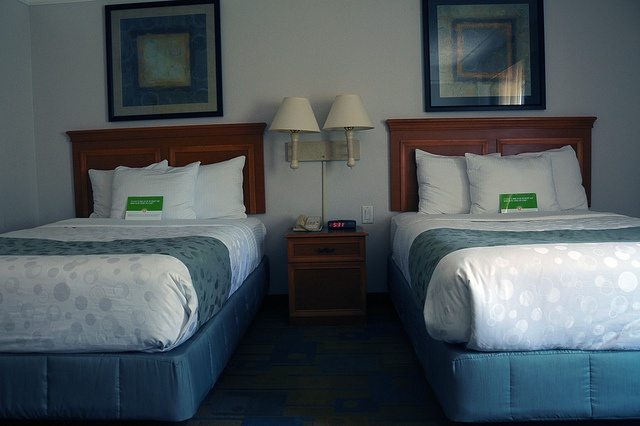Describe the objects in this image and their specific colors. I can see bed in purple, lightgray, black, darkgray, and gray tones, bed in purple, black, darkgray, gray, and darkblue tones, and clock in purple, black, maroon, brown, and red tones in this image. 